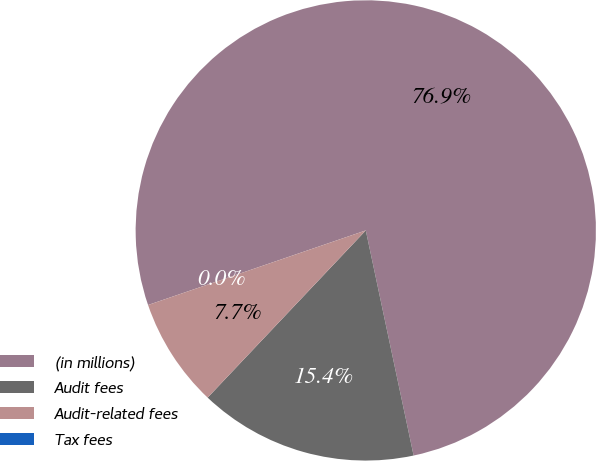Convert chart to OTSL. <chart><loc_0><loc_0><loc_500><loc_500><pie_chart><fcel>(in millions)<fcel>Audit fees<fcel>Audit-related fees<fcel>Tax fees<nl><fcel>76.92%<fcel>15.39%<fcel>7.69%<fcel>0.0%<nl></chart> 